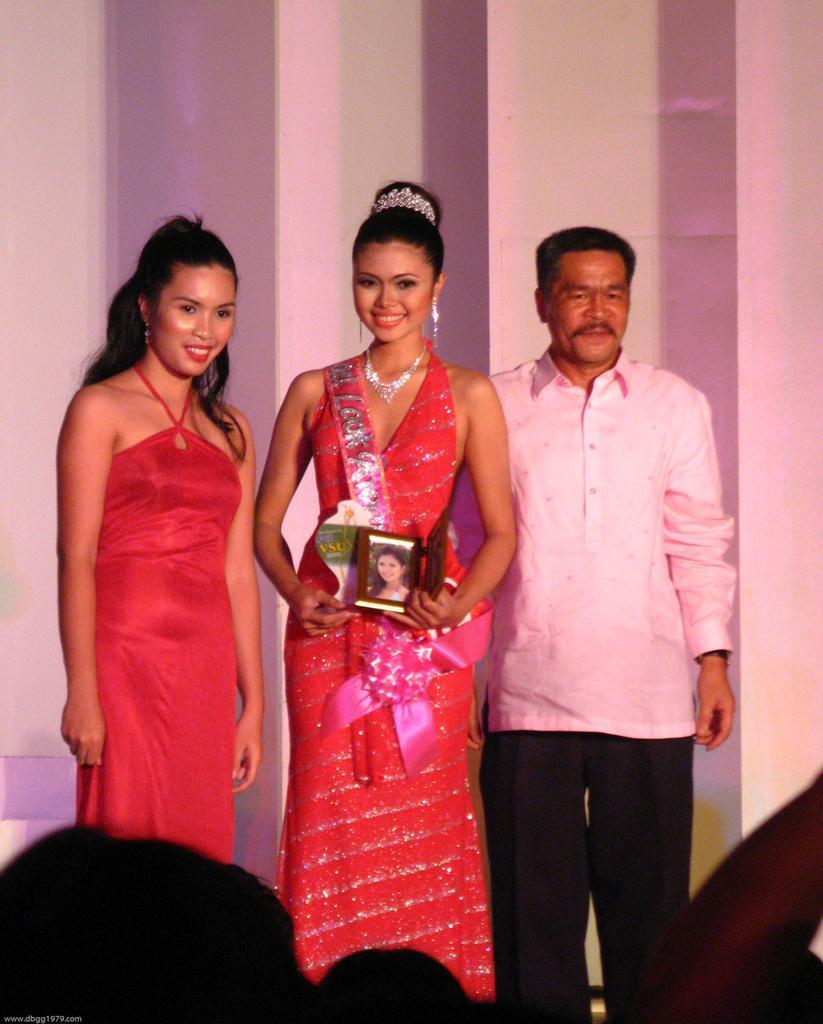How would you summarize this image in a sentence or two? In this image we can see a few people, one of them is holding a photo frame, behind them there is the wall. 